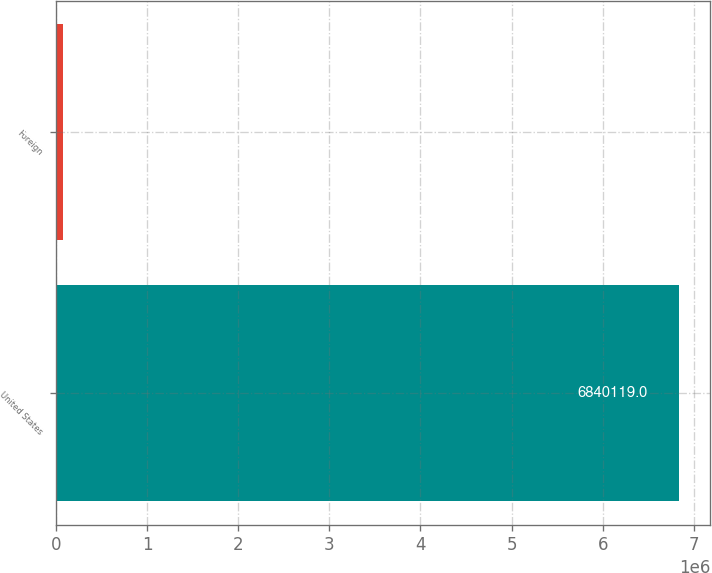Convert chart to OTSL. <chart><loc_0><loc_0><loc_500><loc_500><bar_chart><fcel>United States<fcel>Foreign<nl><fcel>6.84012e+06<fcel>81437<nl></chart> 